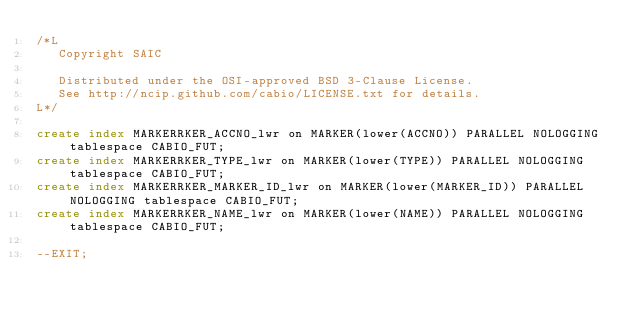<code> <loc_0><loc_0><loc_500><loc_500><_SQL_>/*L
   Copyright SAIC

   Distributed under the OSI-approved BSD 3-Clause License.
   See http://ncip.github.com/cabio/LICENSE.txt for details.
L*/

create index MARKERRKER_ACCNO_lwr on MARKER(lower(ACCNO)) PARALLEL NOLOGGING tablespace CABIO_FUT;
create index MARKERRKER_TYPE_lwr on MARKER(lower(TYPE)) PARALLEL NOLOGGING tablespace CABIO_FUT;
create index MARKERRKER_MARKER_ID_lwr on MARKER(lower(MARKER_ID)) PARALLEL NOLOGGING tablespace CABIO_FUT;
create index MARKERRKER_NAME_lwr on MARKER(lower(NAME)) PARALLEL NOLOGGING tablespace CABIO_FUT;

--EXIT;
</code> 